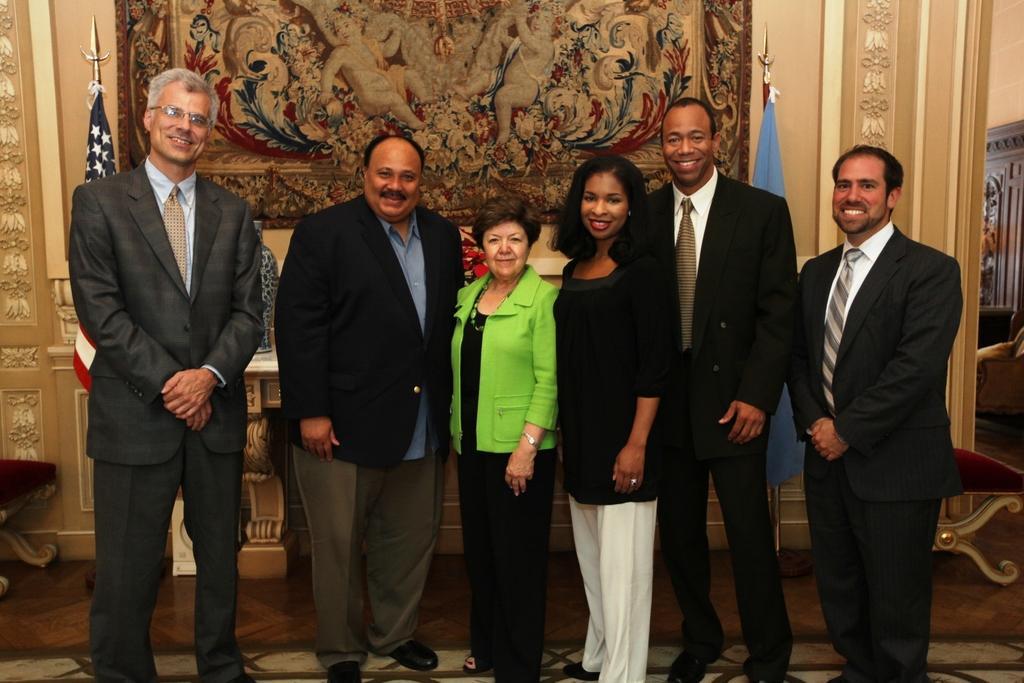Please provide a concise description of this image. In the background we can see a frame on the wall. We can see flags and objects. In this picture we can see people standing and all are smiling. At the bottom portion of the picture we can see the floor. 